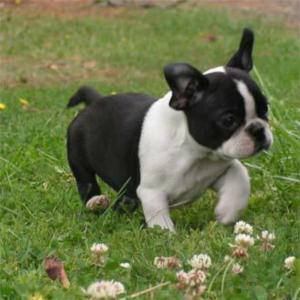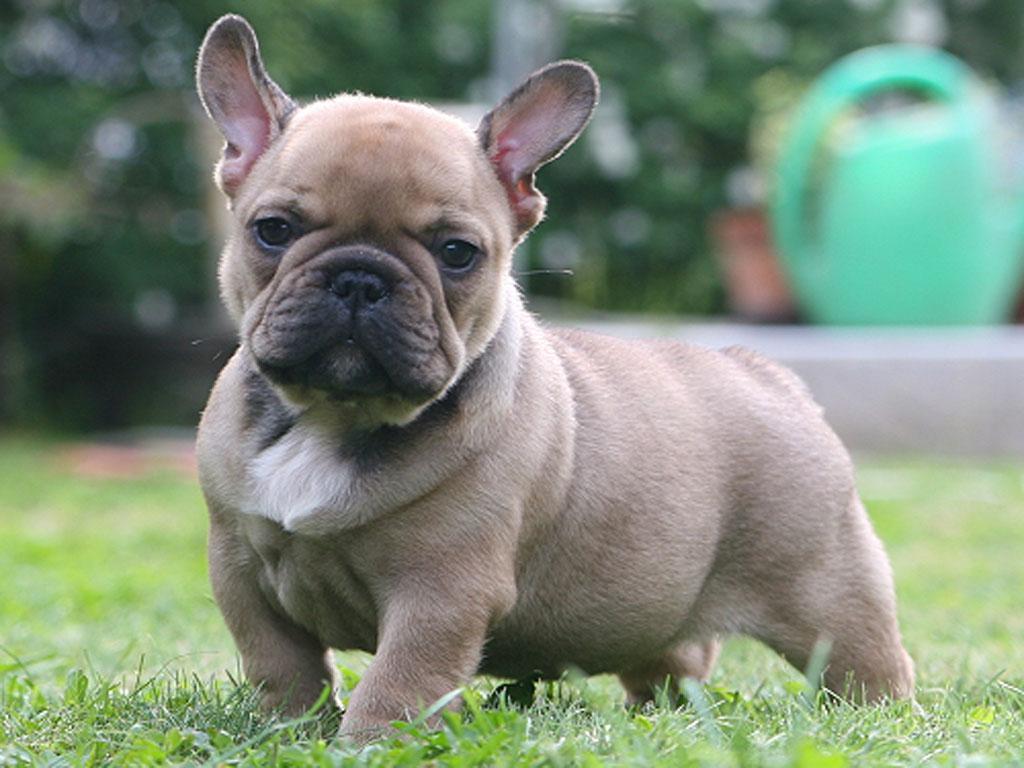The first image is the image on the left, the second image is the image on the right. For the images displayed, is the sentence "One image shows a black and white dog on a field scattered with wild flowers." factually correct? Answer yes or no. Yes. 